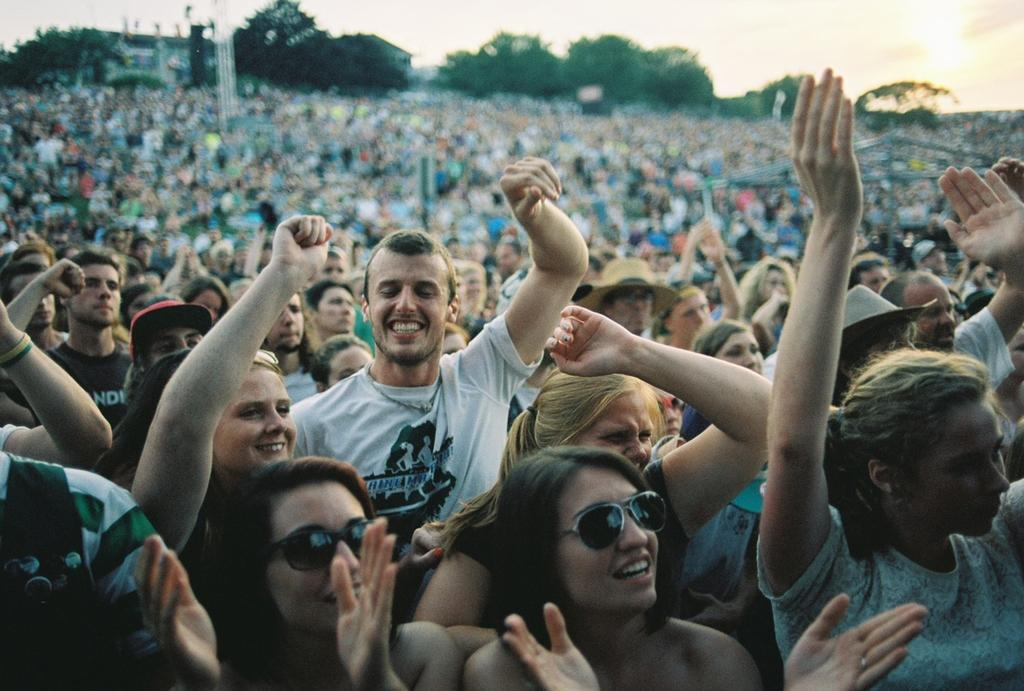How many people are in the image? There are many people in the image. What is the position of the people in the image? The people are standing on the ground. What is the mood of the people in the image? The people are cheerful. What can be seen in the background of the image? There are trees in the background of the image. What is visible above the people in the image? The sky is visible above the people. What type of laborer is using the things in the image? There is no laborer or specific tools or objects mentioned in the image, so it is not possible to answer that question. 